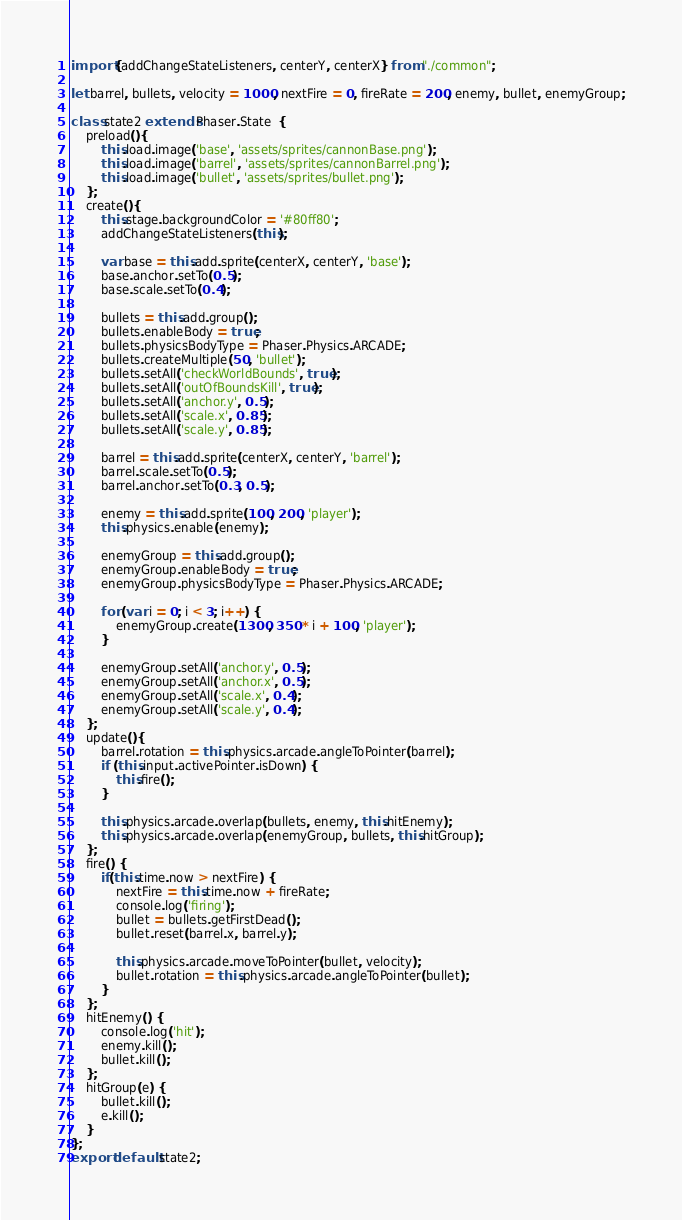<code> <loc_0><loc_0><loc_500><loc_500><_JavaScript_>import {addChangeStateListeners, centerY, centerX} from "./common";

let barrel, bullets, velocity = 1000, nextFire = 0, fireRate = 200, enemy, bullet, enemyGroup;

class state2 extends Phaser.State  {
    preload(){
        this.load.image('base', 'assets/sprites/cannonBase.png');
        this.load.image('barrel', 'assets/sprites/cannonBarrel.png');
        this.load.image('bullet', 'assets/sprites/bullet.png');
    };
    create(){
        this.stage.backgroundColor = '#80ff80';
        addChangeStateListeners(this);

        var base = this.add.sprite(centerX, centerY, 'base');
        base.anchor.setTo(0.5);
        base.scale.setTo(0.4);

        bullets = this.add.group();
        bullets.enableBody = true;
        bullets.physicsBodyType = Phaser.Physics.ARCADE;
        bullets.createMultiple(50, 'bullet');
        bullets.setAll('checkWorldBounds', true);
        bullets.setAll('outOfBoundsKill', true);
        bullets.setAll('anchor.y', 0.5);
        bullets.setAll('scale.x', 0.85);
        bullets.setAll('scale.y', 0.85);

        barrel = this.add.sprite(centerX, centerY, 'barrel');
        barrel.scale.setTo(0.5);
        barrel.anchor.setTo(0.3, 0.5);

        enemy = this.add.sprite(100, 200, 'player');
        this.physics.enable(enemy);

        enemyGroup = this.add.group();
        enemyGroup.enableBody = true;
        enemyGroup.physicsBodyType = Phaser.Physics.ARCADE;

        for (var i = 0; i < 3; i++) {
            enemyGroup.create(1300, 350 * i + 100, 'player');
        }

        enemyGroup.setAll('anchor.y', 0.5);
        enemyGroup.setAll('anchor.x', 0.5);
        enemyGroup.setAll('scale.x', 0.4);
        enemyGroup.setAll('scale.y', 0.4);
    };
    update(){
        barrel.rotation = this.physics.arcade.angleToPointer(barrel);
        if (this.input.activePointer.isDown) {
            this.fire();
        }

        this.physics.arcade.overlap(bullets, enemy, this.hitEnemy);
        this.physics.arcade.overlap(enemyGroup, bullets, this.hitGroup);
    };
    fire() {
        if(this.time.now > nextFire) {
            nextFire = this.time.now + fireRate;
            console.log('firing');
            bullet = bullets.getFirstDead();
            bullet.reset(barrel.x, barrel.y);

            this.physics.arcade.moveToPointer(bullet, velocity);
            bullet.rotation = this.physics.arcade.angleToPointer(bullet);
        }
    };
    hitEnemy() {
        console.log('hit');
        enemy.kill();
        bullet.kill();
    };
    hitGroup(e) {
        bullet.kill();
        e.kill();
    }
};
export default state2;
</code> 